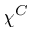Convert formula to latex. <formula><loc_0><loc_0><loc_500><loc_500>\chi ^ { C }</formula> 